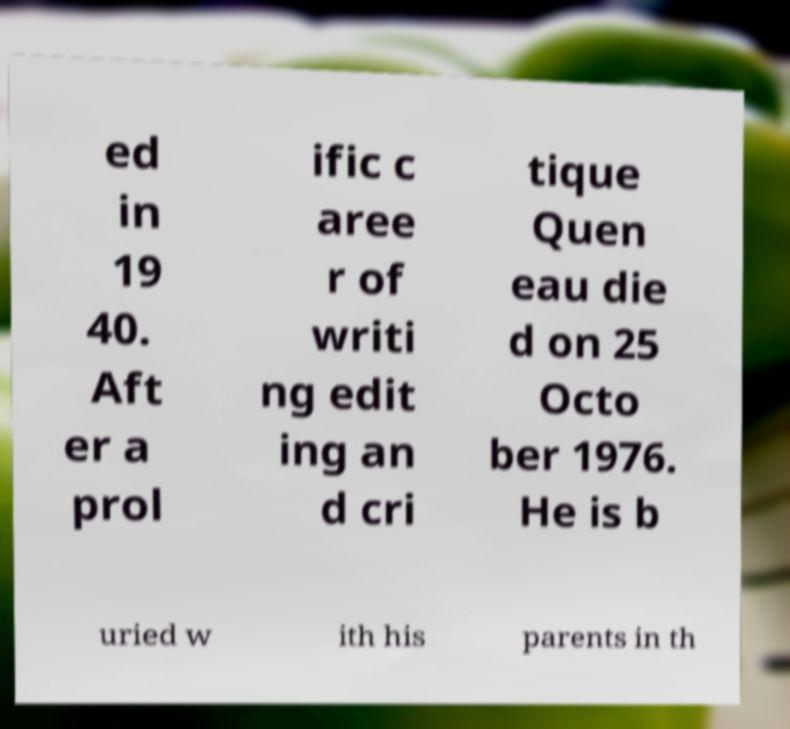Please read and relay the text visible in this image. What does it say? ed in 19 40. Aft er a prol ific c aree r of writi ng edit ing an d cri tique Quen eau die d on 25 Octo ber 1976. He is b uried w ith his parents in th 